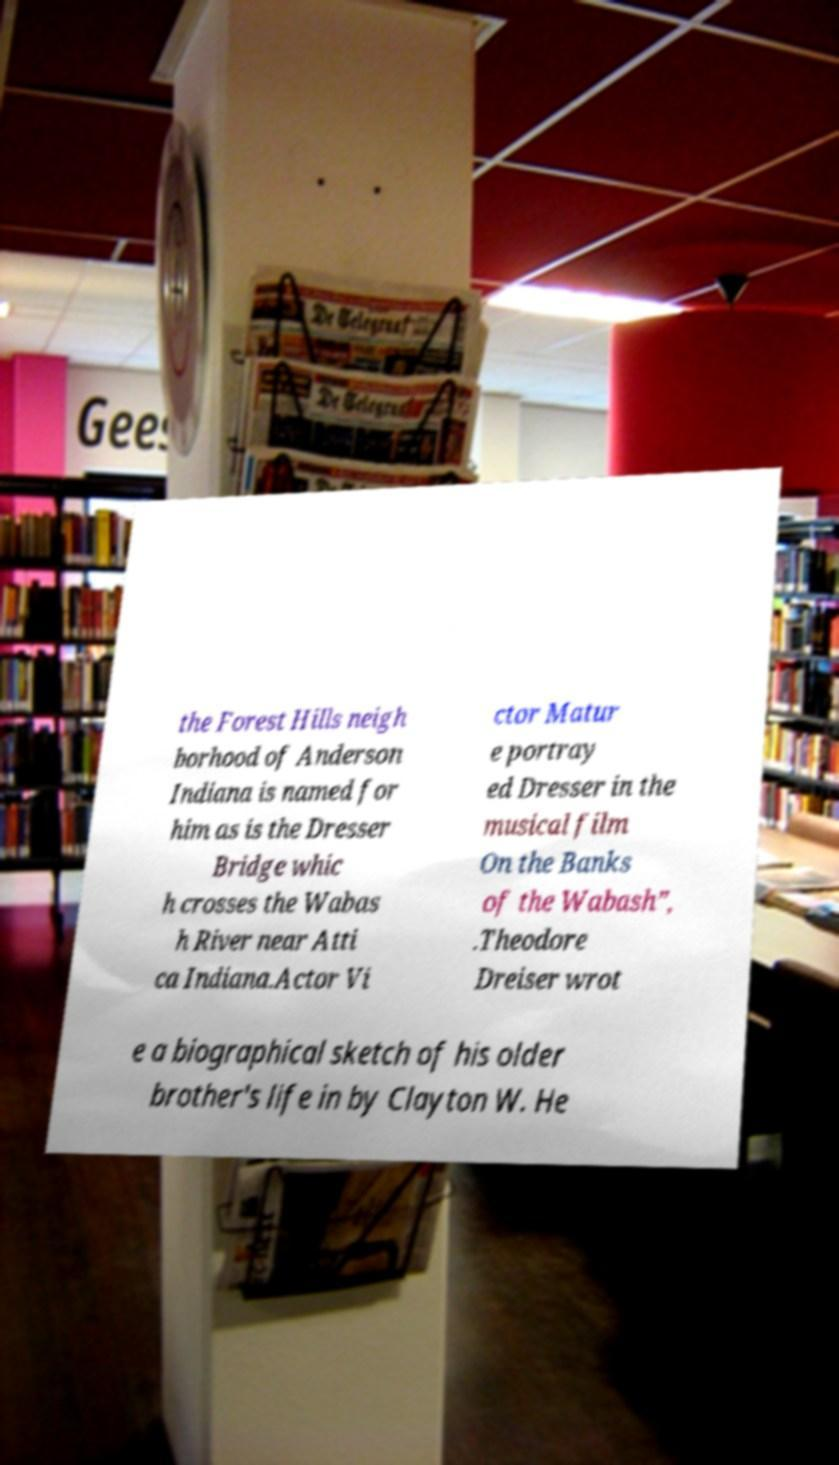Can you accurately transcribe the text from the provided image for me? the Forest Hills neigh borhood of Anderson Indiana is named for him as is the Dresser Bridge whic h crosses the Wabas h River near Atti ca Indiana.Actor Vi ctor Matur e portray ed Dresser in the musical film On the Banks of the Wabash”, .Theodore Dreiser wrot e a biographical sketch of his older brother's life in by Clayton W. He 